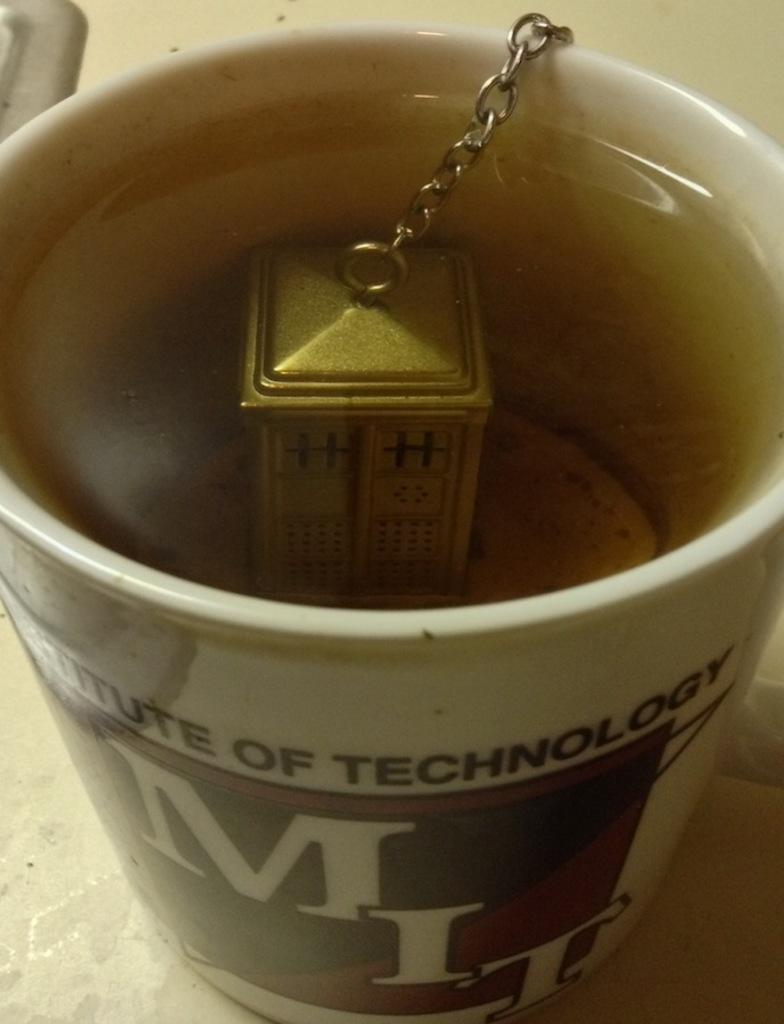<image>
Describe the image concisely. A mug from MIT has a Tardis-shaped tea infuser inside of it. 